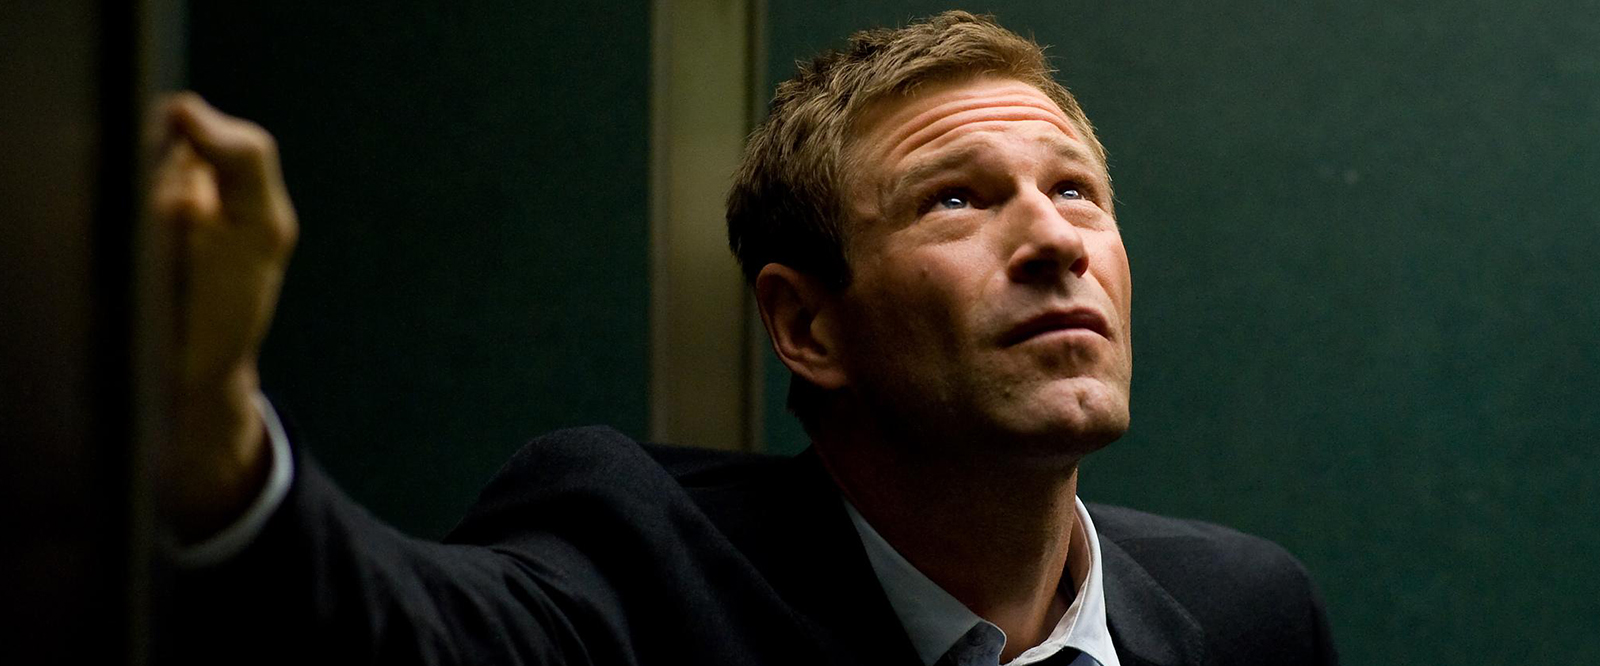What are the key elements in this picture? In this image, we see the actor Aaron Eckhart immersed in a scene from a movie. He is standing against a backdrop of a green wall, his right hand lightly resting on it. His left hand is gripping a railing, suggesting he is on a staircase or balcony. Dressed in a dark suit and tie, he exudes an air of formality. His gaze is directed upwards and to the right, and his expression is one of concern, indicating that he is deeply engrossed in the unfolding events of the scene. 